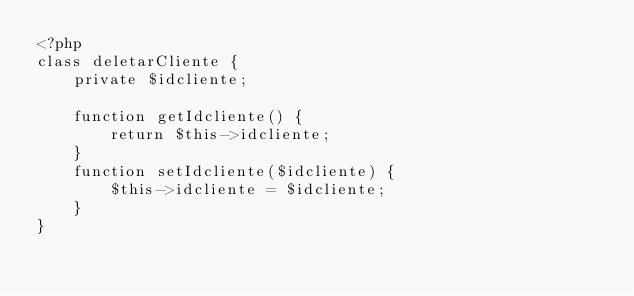Convert code to text. <code><loc_0><loc_0><loc_500><loc_500><_PHP_><?php
class deletarCliente {  
    private $idcliente;
  
    function getIdcliente() {
        return $this->idcliente;
    }
    function setIdcliente($idcliente) {
        $this->idcliente = $idcliente;
    }    
}</code> 